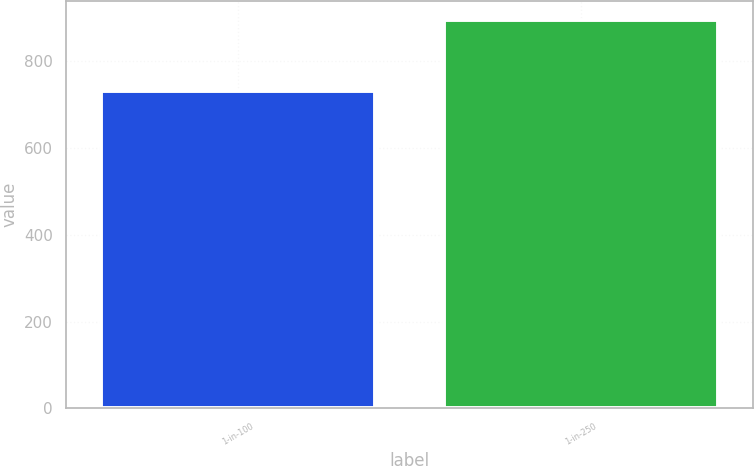<chart> <loc_0><loc_0><loc_500><loc_500><bar_chart><fcel>1-in-100<fcel>1-in-250<nl><fcel>731<fcel>895<nl></chart> 